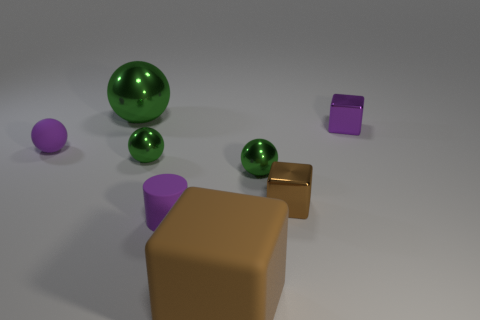Do the purple metallic object and the big brown thing have the same shape?
Your answer should be compact. Yes. How many things are either metal objects or purple things that are behind the tiny rubber cylinder?
Your answer should be very brief. 6. What number of tiny matte objects are there?
Keep it short and to the point. 2. Are there any purple matte things of the same size as the purple cylinder?
Keep it short and to the point. Yes. Is the number of brown things that are to the right of the brown shiny block less than the number of small blocks?
Give a very brief answer. Yes. Do the purple ball and the brown rubber block have the same size?
Your answer should be very brief. No. What size is the purple cube that is made of the same material as the small brown block?
Offer a terse response. Small. How many large matte objects are the same color as the tiny rubber sphere?
Your response must be concise. 0. Are there fewer large green shiny objects that are behind the big brown cube than small purple things that are right of the purple sphere?
Your answer should be very brief. Yes. Does the purple rubber thing on the left side of the big green shiny object have the same shape as the big green metallic thing?
Provide a succinct answer. Yes. 